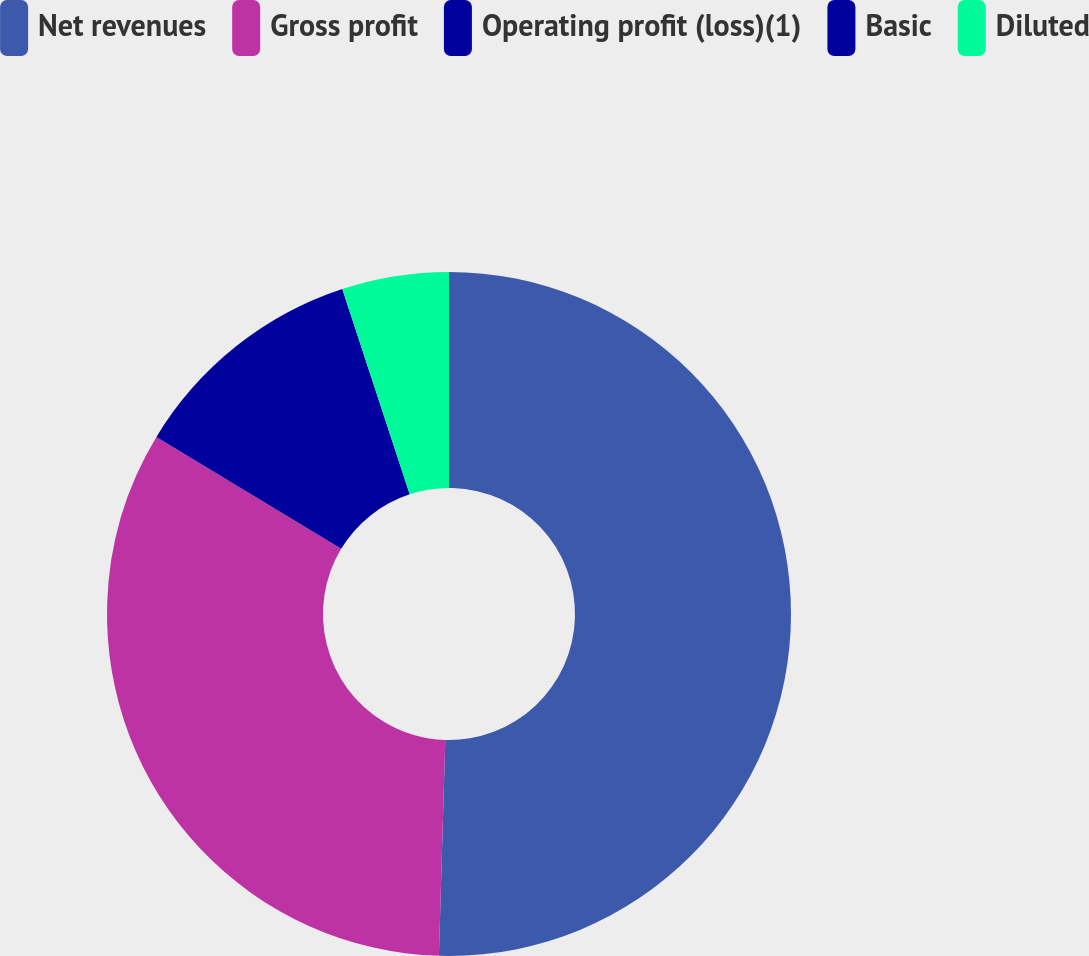Convert chart. <chart><loc_0><loc_0><loc_500><loc_500><pie_chart><fcel>Net revenues<fcel>Gross profit<fcel>Operating profit (loss)(1)<fcel>Basic<fcel>Diluted<nl><fcel>50.47%<fcel>33.19%<fcel>11.29%<fcel>0.0%<fcel>5.05%<nl></chart> 